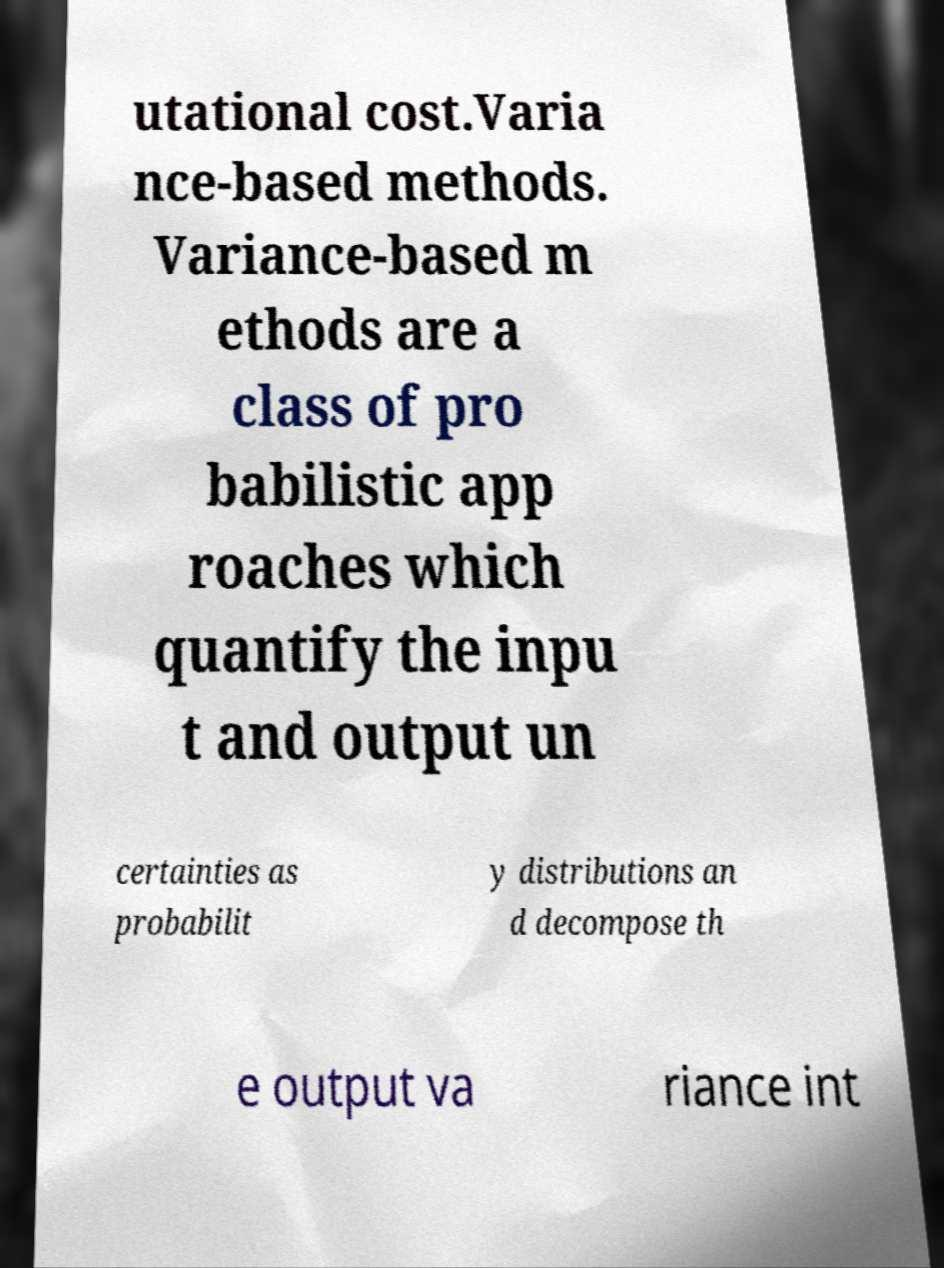Could you extract and type out the text from this image? utational cost.Varia nce-based methods. Variance-based m ethods are a class of pro babilistic app roaches which quantify the inpu t and output un certainties as probabilit y distributions an d decompose th e output va riance int 